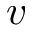<formula> <loc_0><loc_0><loc_500><loc_500>v</formula> 